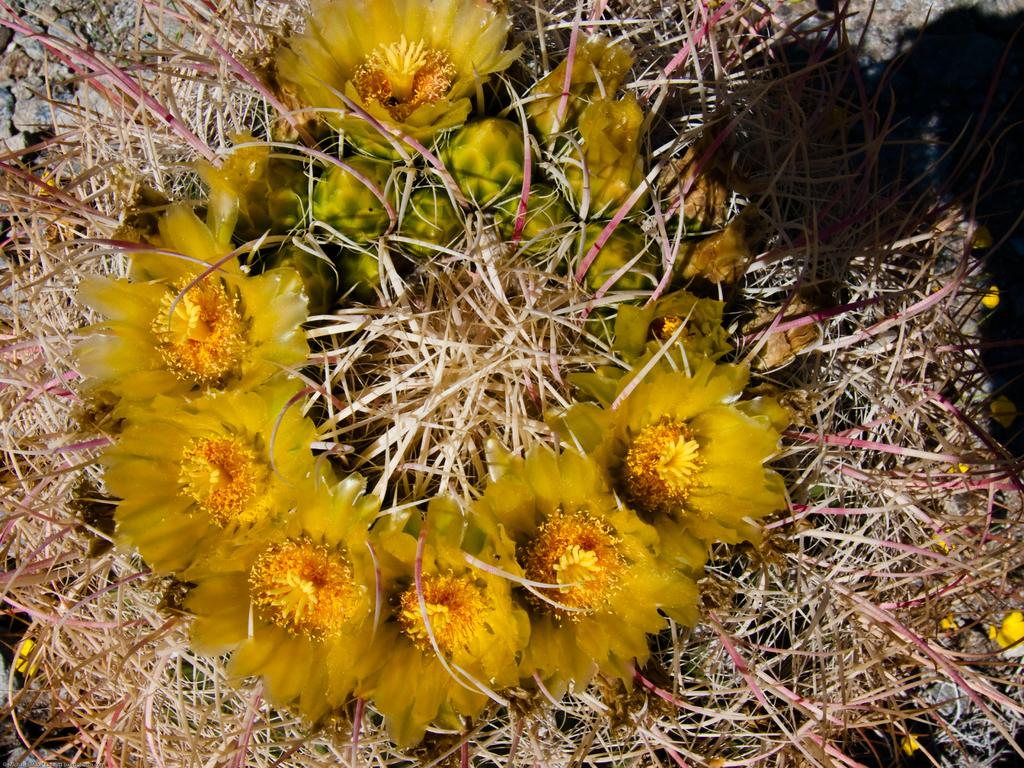What type of plants can be seen in the image? There are flowers in the image. What color are the flowers? The flowers are yellow in color. What else is present in the image besides the flowers? There are stones in the image. What type of produce can be seen growing in the image? There is no produce visible in the image; it features flowers and stones. How many feet are visible in the image? There are no feet present in the image. 